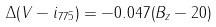<formula> <loc_0><loc_0><loc_500><loc_500>\Delta ( V - i _ { 7 7 5 } ) = - 0 . 0 4 7 ( B _ { z } - 2 0 )</formula> 